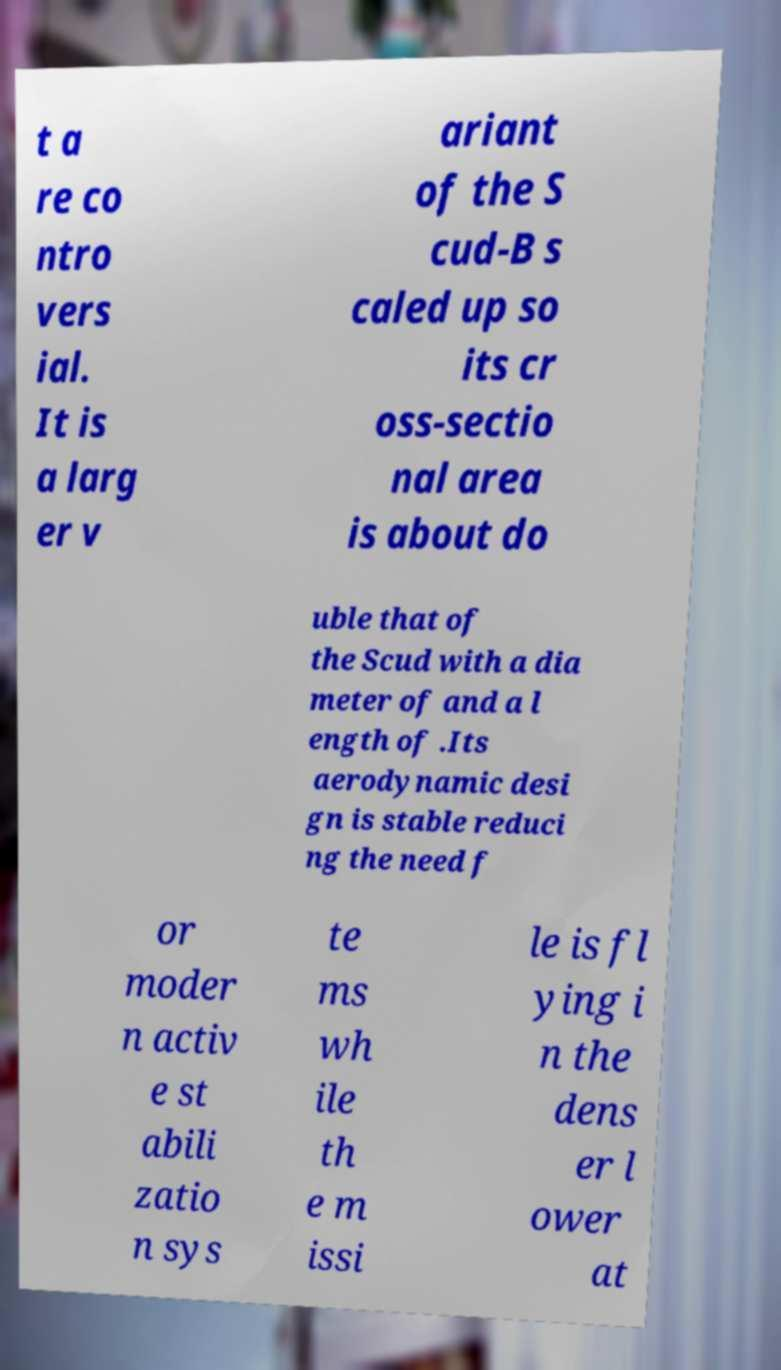Please identify and transcribe the text found in this image. t a re co ntro vers ial. It is a larg er v ariant of the S cud-B s caled up so its cr oss-sectio nal area is about do uble that of the Scud with a dia meter of and a l ength of .Its aerodynamic desi gn is stable reduci ng the need f or moder n activ e st abili zatio n sys te ms wh ile th e m issi le is fl ying i n the dens er l ower at 